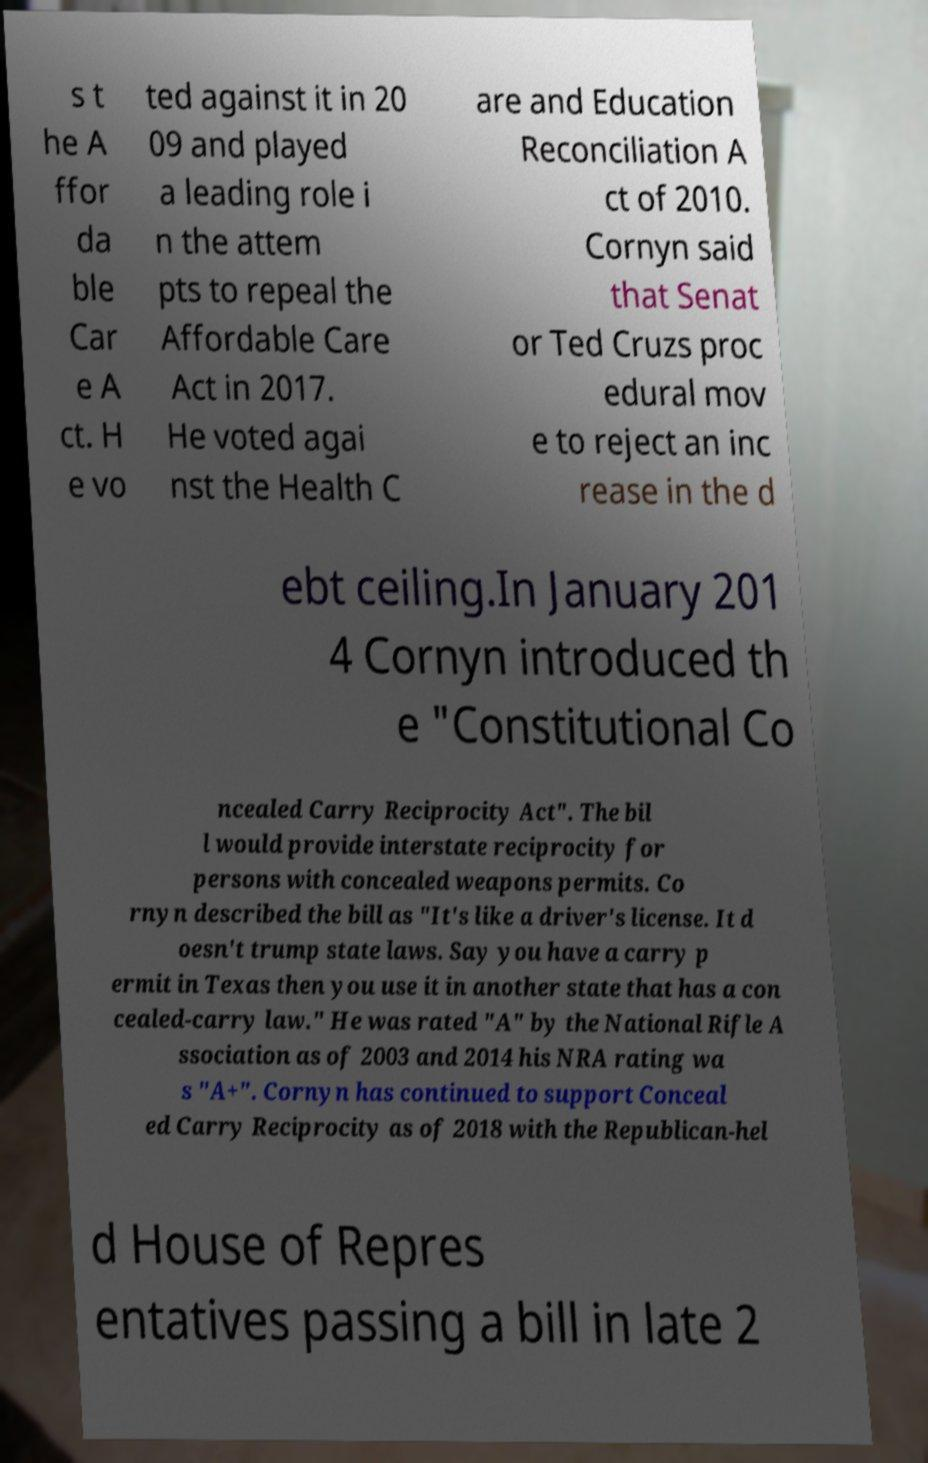Can you accurately transcribe the text from the provided image for me? s t he A ffor da ble Car e A ct. H e vo ted against it in 20 09 and played a leading role i n the attem pts to repeal the Affordable Care Act in 2017. He voted agai nst the Health C are and Education Reconciliation A ct of 2010. Cornyn said that Senat or Ted Cruzs proc edural mov e to reject an inc rease in the d ebt ceiling.In January 201 4 Cornyn introduced th e "Constitutional Co ncealed Carry Reciprocity Act". The bil l would provide interstate reciprocity for persons with concealed weapons permits. Co rnyn described the bill as "It's like a driver's license. It d oesn't trump state laws. Say you have a carry p ermit in Texas then you use it in another state that has a con cealed-carry law." He was rated "A" by the National Rifle A ssociation as of 2003 and 2014 his NRA rating wa s "A+". Cornyn has continued to support Conceal ed Carry Reciprocity as of 2018 with the Republican-hel d House of Repres entatives passing a bill in late 2 